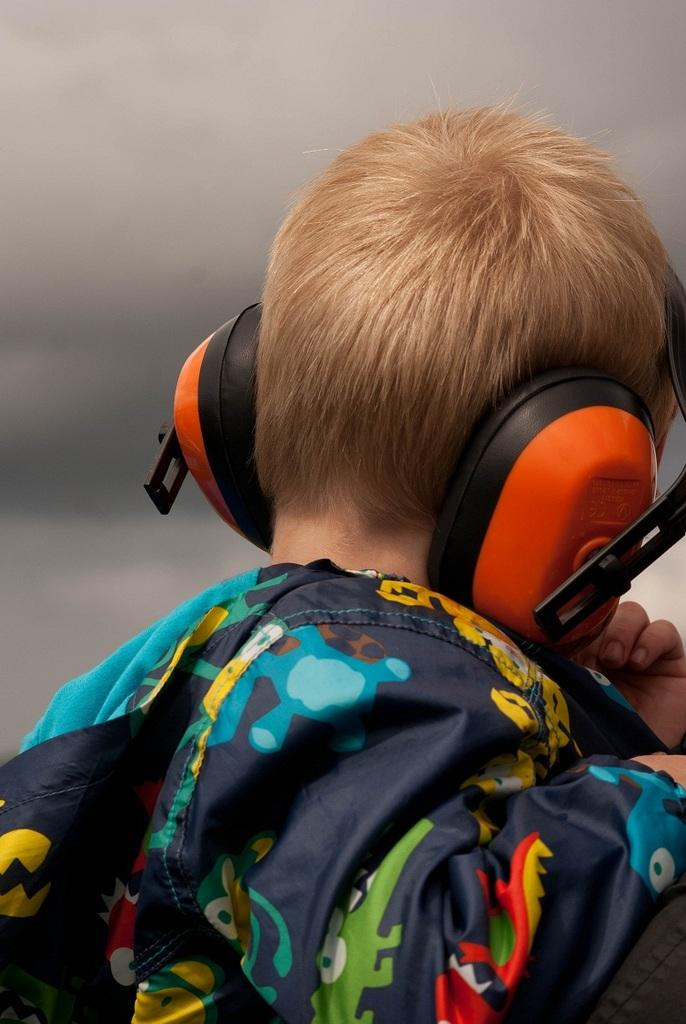Who is the main subject in the image? There is a boy in the image. What is the boy wearing on his ears? The boy is wearing headphones. What type of clothing is the boy wearing? The boy is wearing a colorful dress. What is visible at the top of the image? The sky is visible at the top of the image. Can you see any fangs on the boy in the image? There are no fangs visible on the boy in the image. What type of cactus is growing near the boy in the image? There is no cactus present in the image. 